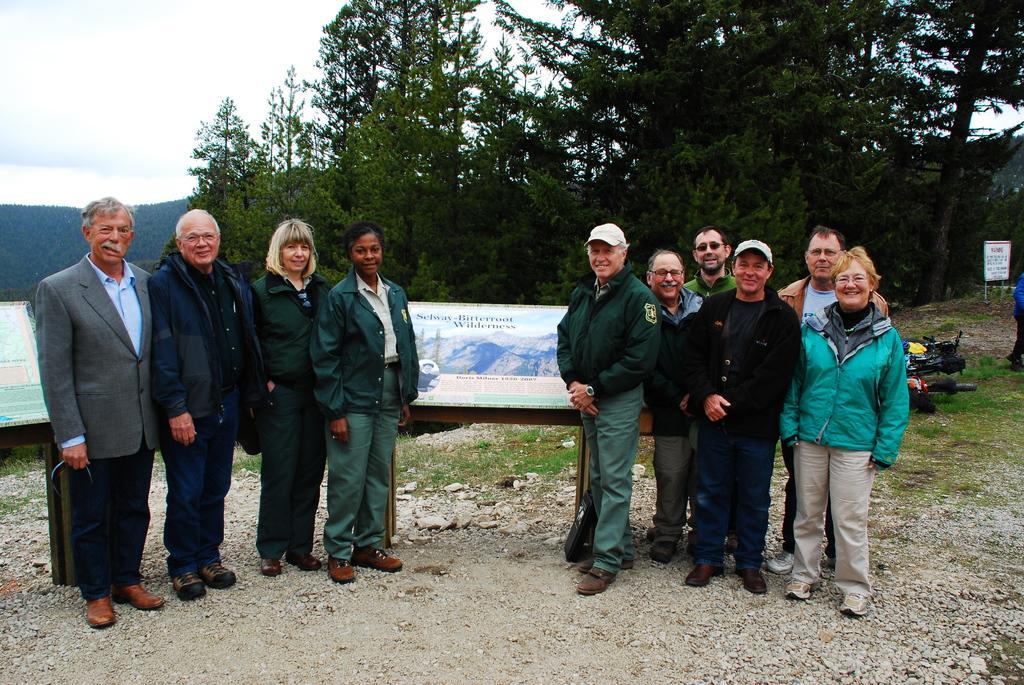Describe this image in one or two sentences. There are two groups of persons standing and smiling on the ground. In the background, there are two hoardings, there are trees, mountain and clouds in the sky. 